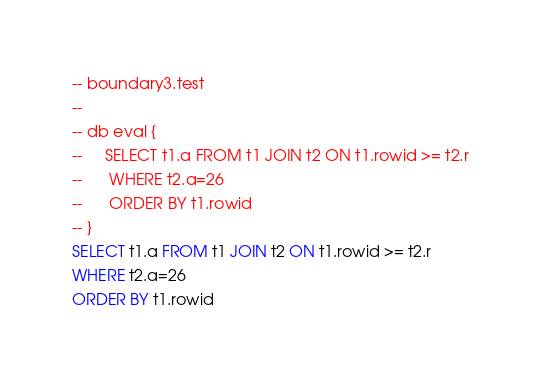Convert code to text. <code><loc_0><loc_0><loc_500><loc_500><_SQL_>-- boundary3.test
-- 
-- db eval {
--     SELECT t1.a FROM t1 JOIN t2 ON t1.rowid >= t2.r
--      WHERE t2.a=26
--      ORDER BY t1.rowid
-- }
SELECT t1.a FROM t1 JOIN t2 ON t1.rowid >= t2.r
WHERE t2.a=26
ORDER BY t1.rowid</code> 